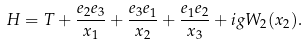<formula> <loc_0><loc_0><loc_500><loc_500>H = T + \frac { e _ { 2 } e _ { 3 } } { x _ { 1 } } + \frac { e _ { 3 } e _ { 1 } } { x _ { 2 } } + \frac { e _ { 1 } e _ { 2 } } { x _ { 3 } } + i g W _ { 2 } ( { x } _ { 2 } ) .</formula> 